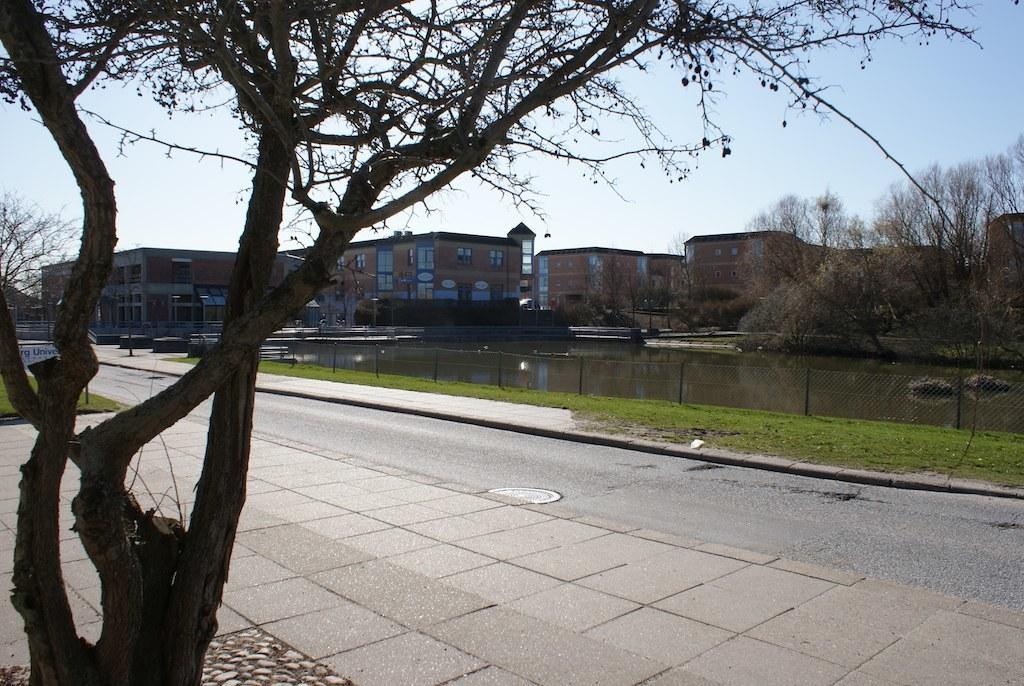What type of vegetation can be seen in the image? There are trees and grass visible in the image. What is the texture of the mesh in the image? The mesh in the image has a net-like texture. What is the liquid element present in the image? There is water visible in the image. What type of structures are present in the image? There are buildings in the image, and they have windows. What part of the natural environment is visible in the image? The sky is visible in the background of the image. How many chairs are placed around the jelly in the image? There are no chairs or jelly present in the image. What type of slave is depicted in the image? There is no depiction of a slave in the image; it features trees, grass, water, buildings, and the sky. 